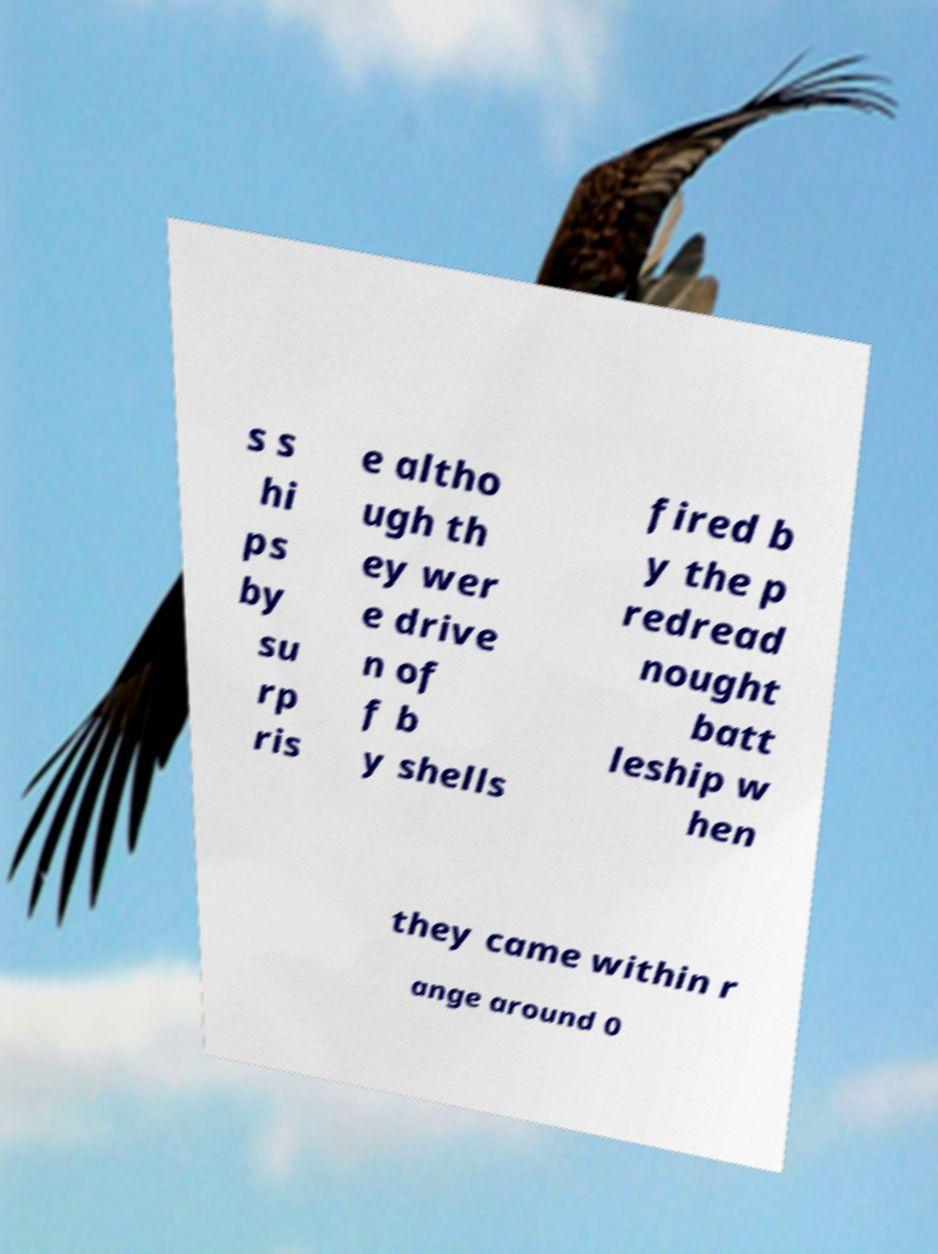Could you extract and type out the text from this image? s s hi ps by su rp ris e altho ugh th ey wer e drive n of f b y shells fired b y the p redread nought batt leship w hen they came within r ange around 0 